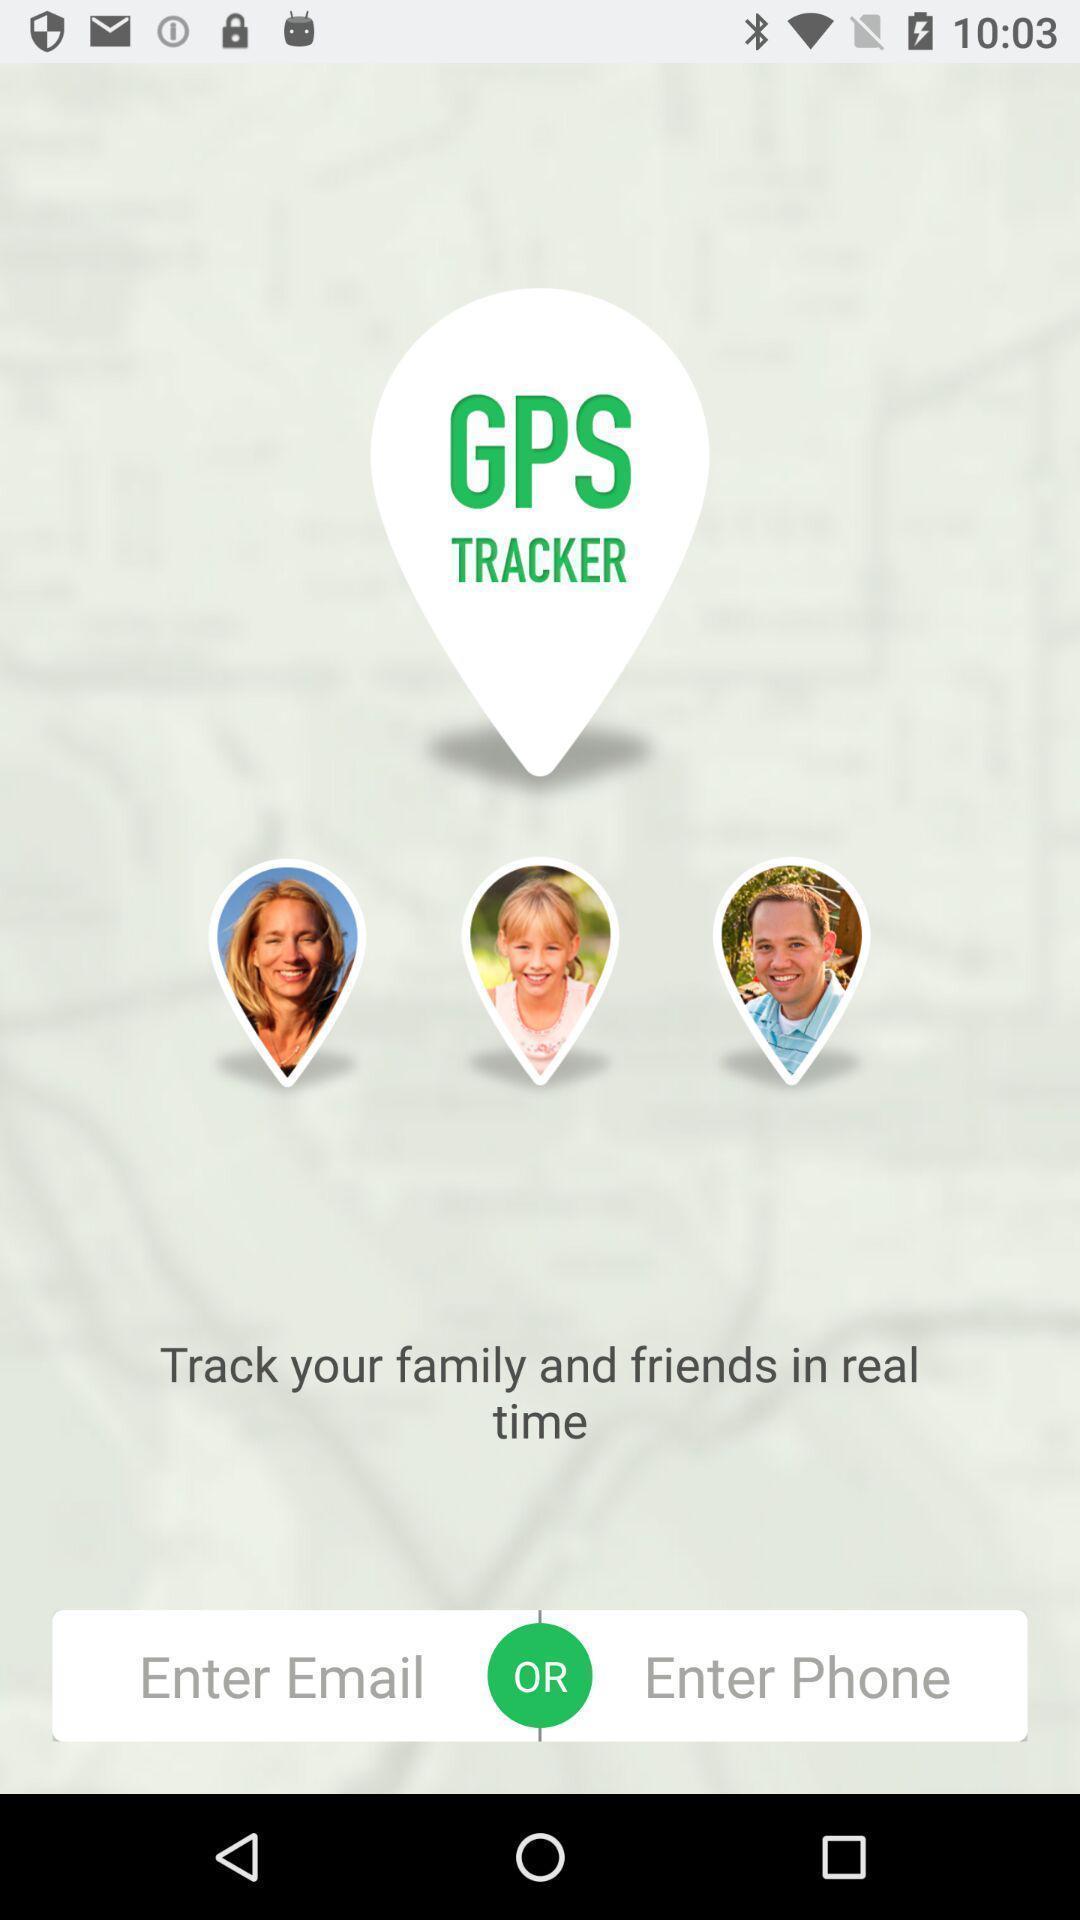Provide a textual representation of this image. Welcome page of an mapping application. 